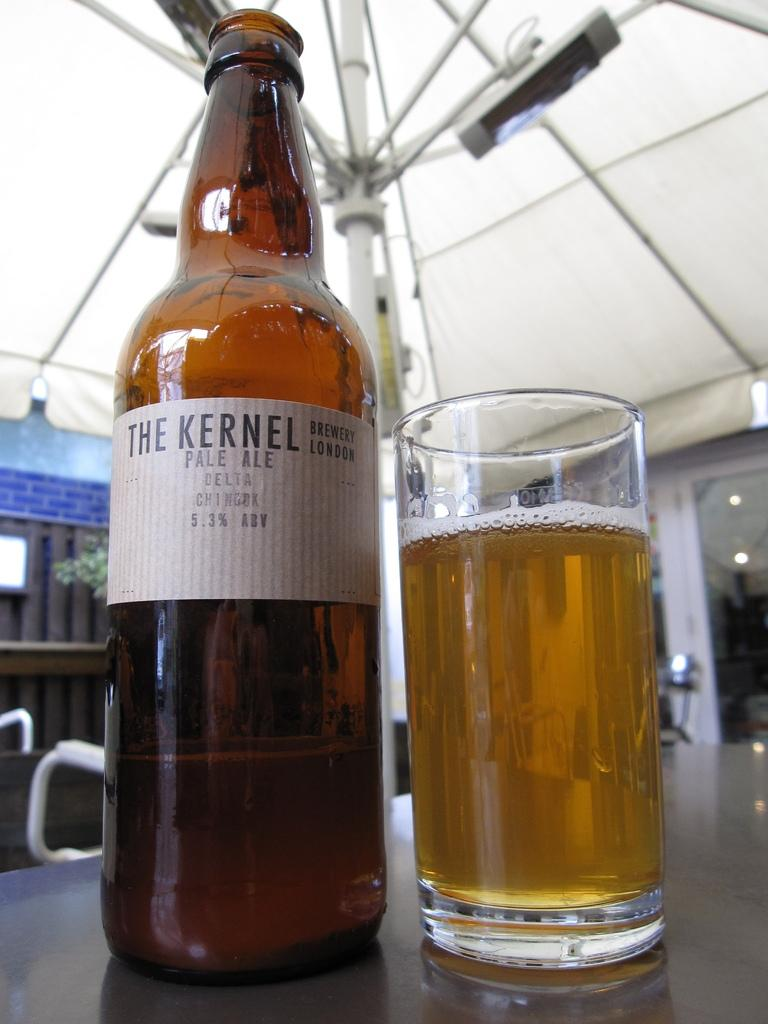Provide a one-sentence caption for the provided image. Glass of beer next to a "The Kernel" beer bottle. 